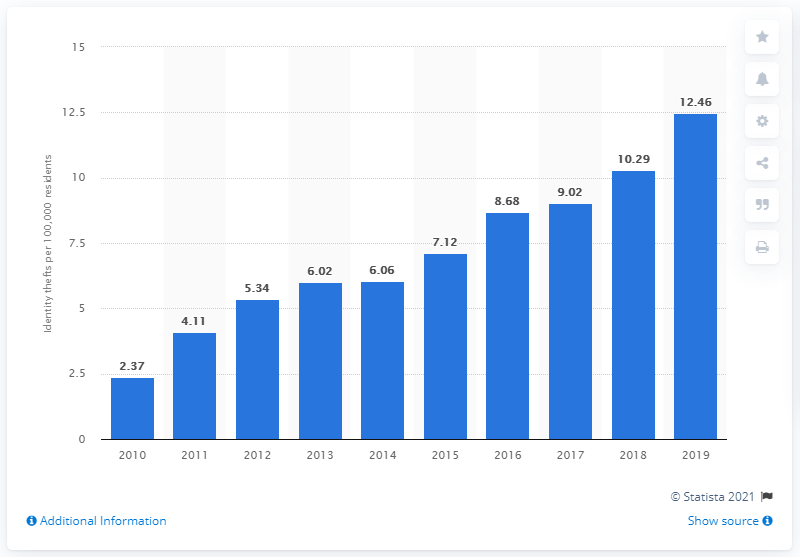Indicate a few pertinent items in this graphic. In 2019, there were an estimated 12.46 incidents of identity theft per 100,000 residents in Canada. 